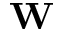<formula> <loc_0><loc_0><loc_500><loc_500>W</formula> 